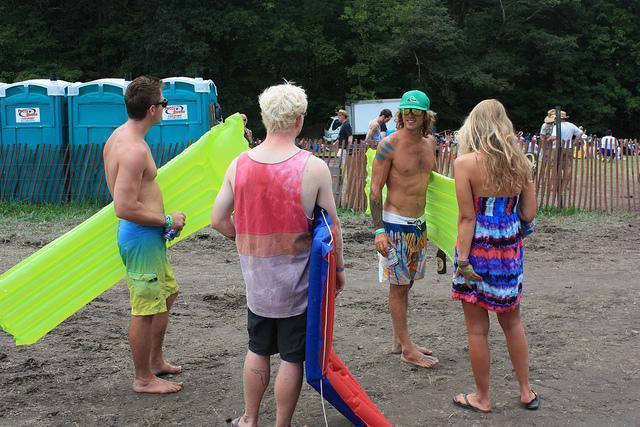Why is the guy's neck red?
Pick the correct solution from the four options below to address the question.
Options: Hair dye, makeup, blushing, sunburn. Sunburn. 